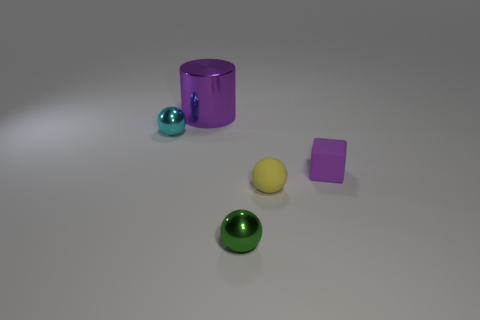What is the material of the green object?
Your answer should be compact. Metal. What material is the green object that is the same shape as the tiny cyan shiny object?
Provide a succinct answer. Metal. There is a tiny thing that is to the right of the small yellow matte thing in front of the small cyan ball; what color is it?
Ensure brevity in your answer.  Purple. How many metallic objects are yellow spheres or large purple cylinders?
Your answer should be compact. 1. Does the green ball have the same material as the large cylinder?
Your answer should be compact. Yes. There is a tiny ball on the left side of the small shiny object that is in front of the small rubber sphere; what is its material?
Offer a very short reply. Metal. What number of large objects are matte things or cyan rubber cylinders?
Offer a very short reply. 0. The purple cylinder is what size?
Provide a short and direct response. Large. Are there more green spheres behind the big metallic object than big cyan metal blocks?
Make the answer very short. No. Are there the same number of shiny balls that are behind the purple metal cylinder and small cyan metal spheres that are in front of the small purple block?
Keep it short and to the point. Yes. 